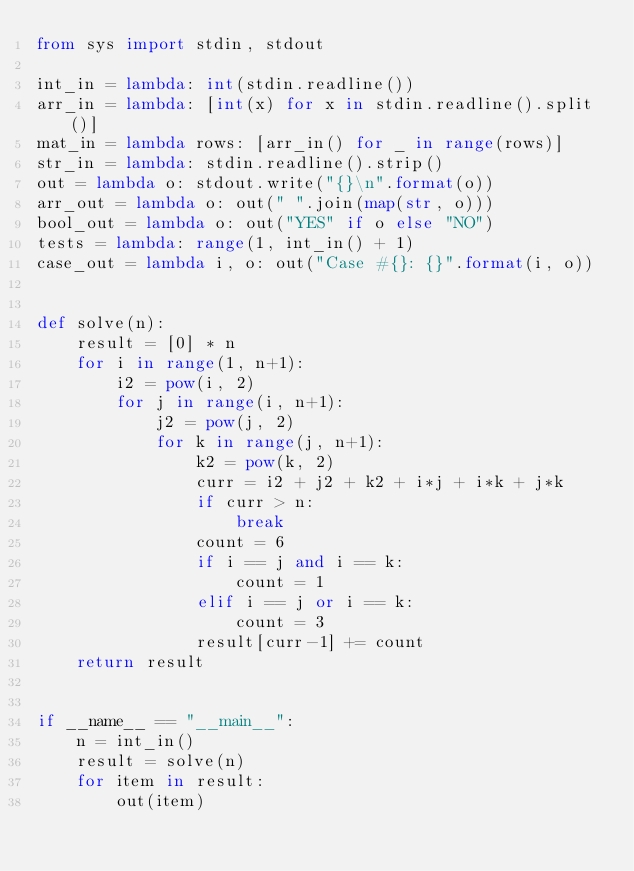<code> <loc_0><loc_0><loc_500><loc_500><_Python_>from sys import stdin, stdout

int_in = lambda: int(stdin.readline())
arr_in = lambda: [int(x) for x in stdin.readline().split()]
mat_in = lambda rows: [arr_in() for _ in range(rows)]
str_in = lambda: stdin.readline().strip()
out = lambda o: stdout.write("{}\n".format(o))
arr_out = lambda o: out(" ".join(map(str, o)))
bool_out = lambda o: out("YES" if o else "NO")
tests = lambda: range(1, int_in() + 1)
case_out = lambda i, o: out("Case #{}: {}".format(i, o))


def solve(n):
    result = [0] * n
    for i in range(1, n+1):
        i2 = pow(i, 2)
        for j in range(i, n+1):
            j2 = pow(j, 2)
            for k in range(j, n+1):
                k2 = pow(k, 2)
                curr = i2 + j2 + k2 + i*j + i*k + j*k
                if curr > n:
                    break
                count = 6
                if i == j and i == k:
                    count = 1
                elif i == j or i == k:
                    count = 3
                result[curr-1] += count
    return result


if __name__ == "__main__":
    n = int_in()
    result = solve(n)
    for item in result:
        out(item)</code> 